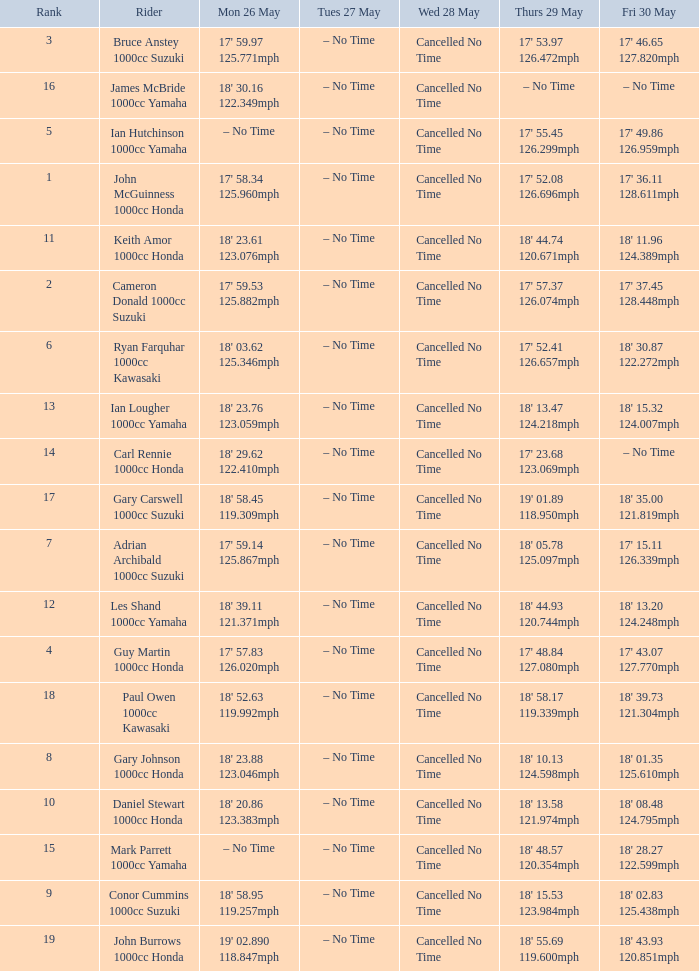What is the numbr for fri may 30 and mon may 26 is 19' 02.890 118.847mph? 18' 43.93 120.851mph. 